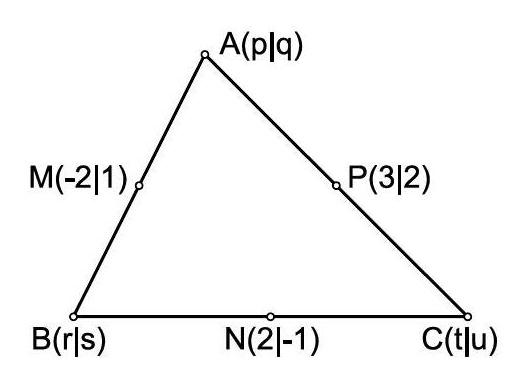Can you explain how to find the coordinates of the vertices using the given midpoints? Certainly! Given the midpoints, you can use the midpoint formula in reverse. Taking $M(-2, 1)$ for example, which is the midpoint of $AB$, you equate $(-2, 1)$ to $((p+r)/2, (q+s)/2)$. Repeat this for the other midpoints, $N$ and $P$, to establish a system of equations. Solving these equations will give you the coordinates for the vertices $A$, $B$, and $C$. 